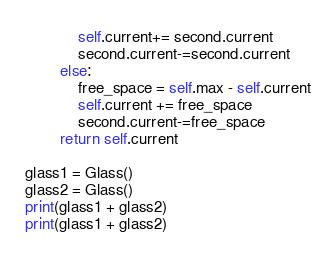<code> <loc_0><loc_0><loc_500><loc_500><_Python_>            self.current+= second.current
            second.current-=second.current
        else:
            free_space = self.max - self.current
            self.current += free_space
            second.current-=free_space
        return self.current

glass1 = Glass()
glass2 = Glass()
print(glass1 + glass2)
print(glass1 + glass2)</code> 